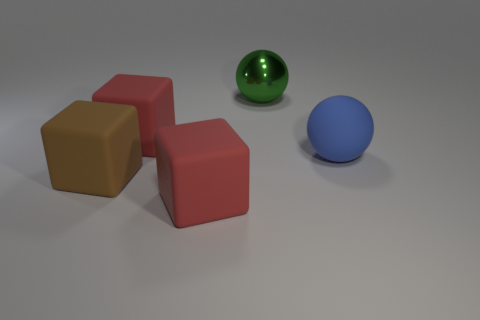The large shiny thing is what color?
Provide a succinct answer. Green. What number of big brown things are to the left of the big red cube behind the large brown matte thing?
Offer a very short reply. 1. Are there any blocks in front of the large thing right of the large metal thing?
Provide a short and direct response. Yes. Are there any matte things to the right of the brown rubber block?
Your response must be concise. Yes. There is a large red thing in front of the large brown matte block; does it have the same shape as the large brown object?
Provide a succinct answer. Yes. What number of small purple rubber objects have the same shape as the green object?
Offer a very short reply. 0. Is there another big thing that has the same material as the blue object?
Provide a succinct answer. Yes. The red block that is behind the large ball that is in front of the big metal object is made of what material?
Provide a short and direct response. Rubber. How big is the red thing that is behind the big brown matte block?
Your response must be concise. Large. Do the brown thing and the large red object in front of the brown matte block have the same material?
Provide a succinct answer. Yes. 